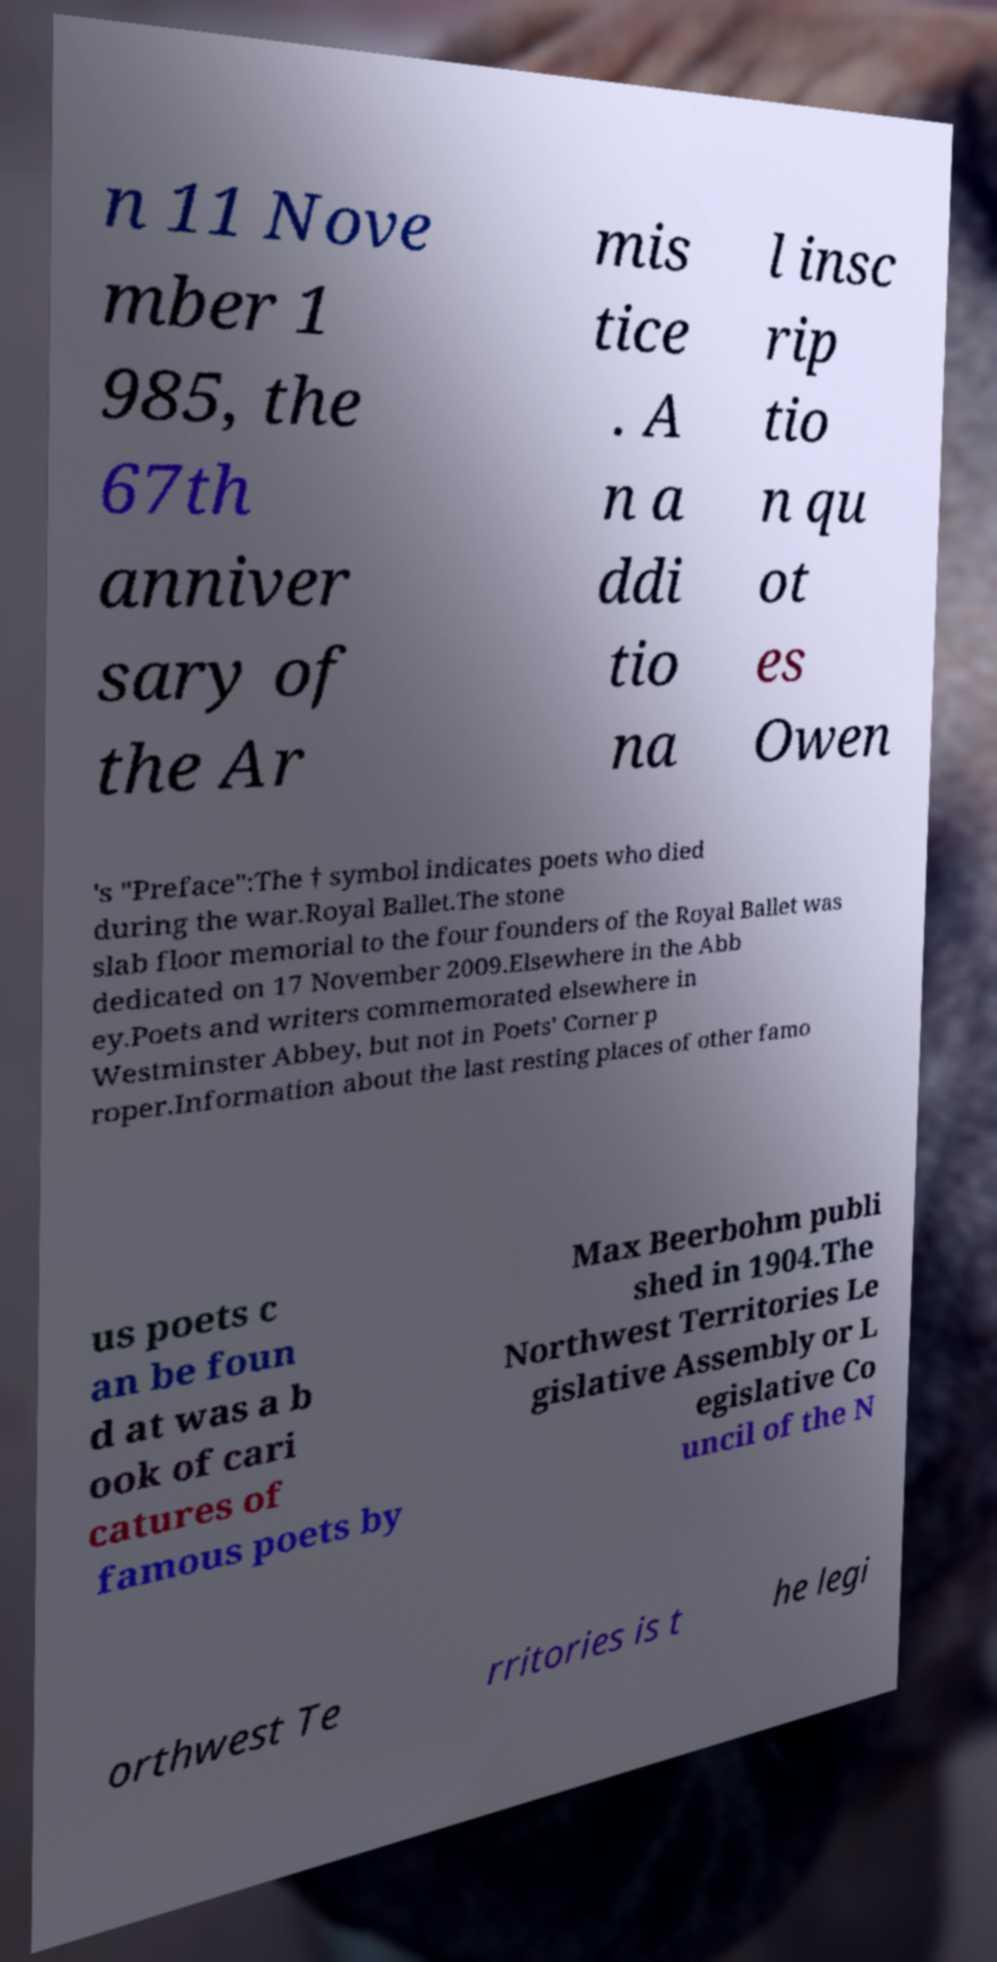Can you read and provide the text displayed in the image?This photo seems to have some interesting text. Can you extract and type it out for me? n 11 Nove mber 1 985, the 67th anniver sary of the Ar mis tice . A n a ddi tio na l insc rip tio n qu ot es Owen 's "Preface":The † symbol indicates poets who died during the war.Royal Ballet.The stone slab floor memorial to the four founders of the Royal Ballet was dedicated on 17 November 2009.Elsewhere in the Abb ey.Poets and writers commemorated elsewhere in Westminster Abbey, but not in Poets' Corner p roper.Information about the last resting places of other famo us poets c an be foun d at was a b ook of cari catures of famous poets by Max Beerbohm publi shed in 1904.The Northwest Territories Le gislative Assembly or L egislative Co uncil of the N orthwest Te rritories is t he legi 